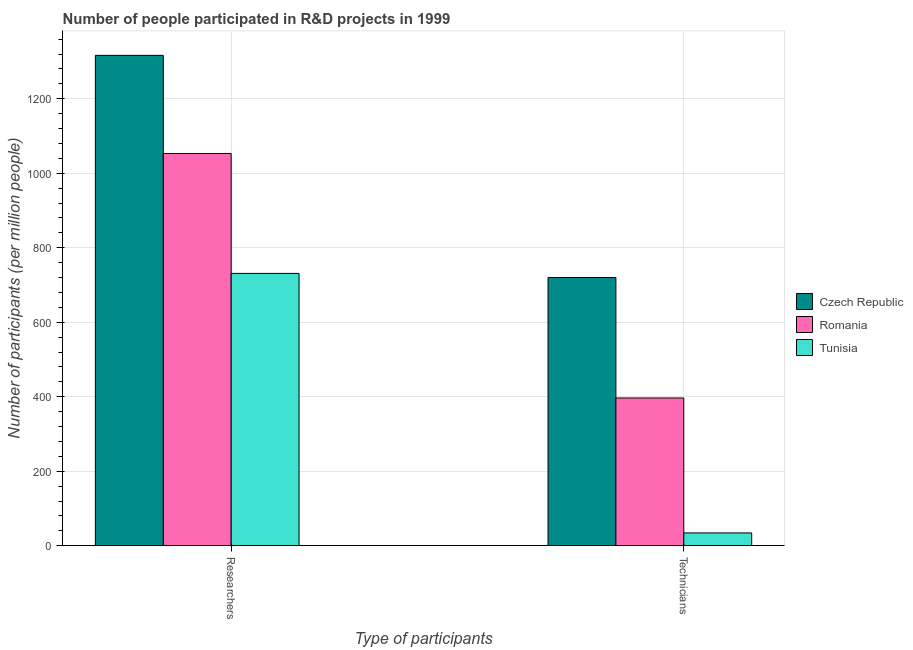How many different coloured bars are there?
Your response must be concise. 3. How many groups of bars are there?
Provide a short and direct response. 2. Are the number of bars per tick equal to the number of legend labels?
Your answer should be compact. Yes. Are the number of bars on each tick of the X-axis equal?
Your response must be concise. Yes. How many bars are there on the 1st tick from the left?
Provide a short and direct response. 3. What is the label of the 1st group of bars from the left?
Offer a very short reply. Researchers. What is the number of researchers in Czech Republic?
Ensure brevity in your answer.  1316.57. Across all countries, what is the maximum number of technicians?
Give a very brief answer. 720.1. Across all countries, what is the minimum number of researchers?
Offer a terse response. 731.21. In which country was the number of researchers maximum?
Provide a short and direct response. Czech Republic. In which country was the number of technicians minimum?
Your response must be concise. Tunisia. What is the total number of researchers in the graph?
Your answer should be compact. 3100.92. What is the difference between the number of researchers in Tunisia and that in Romania?
Provide a succinct answer. -321.93. What is the difference between the number of technicians in Czech Republic and the number of researchers in Romania?
Offer a very short reply. -333.04. What is the average number of researchers per country?
Ensure brevity in your answer.  1033.64. What is the difference between the number of researchers and number of technicians in Czech Republic?
Your answer should be compact. 596.47. In how many countries, is the number of technicians greater than 760 ?
Offer a terse response. 0. What is the ratio of the number of technicians in Romania to that in Czech Republic?
Offer a very short reply. 0.55. What does the 3rd bar from the left in Technicians represents?
Your answer should be compact. Tunisia. What does the 3rd bar from the right in Technicians represents?
Give a very brief answer. Czech Republic. How many bars are there?
Your answer should be compact. 6. Does the graph contain any zero values?
Make the answer very short. No. Does the graph contain grids?
Provide a succinct answer. Yes. How many legend labels are there?
Keep it short and to the point. 3. What is the title of the graph?
Give a very brief answer. Number of people participated in R&D projects in 1999. Does "Guam" appear as one of the legend labels in the graph?
Your answer should be compact. No. What is the label or title of the X-axis?
Your answer should be compact. Type of participants. What is the label or title of the Y-axis?
Make the answer very short. Number of participants (per million people). What is the Number of participants (per million people) of Czech Republic in Researchers?
Your answer should be very brief. 1316.57. What is the Number of participants (per million people) in Romania in Researchers?
Your response must be concise. 1053.14. What is the Number of participants (per million people) of Tunisia in Researchers?
Offer a terse response. 731.21. What is the Number of participants (per million people) of Czech Republic in Technicians?
Ensure brevity in your answer.  720.1. What is the Number of participants (per million people) in Romania in Technicians?
Provide a succinct answer. 396.75. What is the Number of participants (per million people) of Tunisia in Technicians?
Make the answer very short. 34.49. Across all Type of participants, what is the maximum Number of participants (per million people) in Czech Republic?
Provide a succinct answer. 1316.57. Across all Type of participants, what is the maximum Number of participants (per million people) in Romania?
Make the answer very short. 1053.14. Across all Type of participants, what is the maximum Number of participants (per million people) in Tunisia?
Your answer should be very brief. 731.21. Across all Type of participants, what is the minimum Number of participants (per million people) of Czech Republic?
Make the answer very short. 720.1. Across all Type of participants, what is the minimum Number of participants (per million people) of Romania?
Provide a short and direct response. 396.75. Across all Type of participants, what is the minimum Number of participants (per million people) in Tunisia?
Ensure brevity in your answer.  34.49. What is the total Number of participants (per million people) in Czech Republic in the graph?
Your response must be concise. 2036.67. What is the total Number of participants (per million people) of Romania in the graph?
Offer a very short reply. 1449.89. What is the total Number of participants (per million people) in Tunisia in the graph?
Provide a short and direct response. 765.7. What is the difference between the Number of participants (per million people) of Czech Republic in Researchers and that in Technicians?
Make the answer very short. 596.47. What is the difference between the Number of participants (per million people) of Romania in Researchers and that in Technicians?
Your answer should be very brief. 656.39. What is the difference between the Number of participants (per million people) in Tunisia in Researchers and that in Technicians?
Provide a short and direct response. 696.72. What is the difference between the Number of participants (per million people) of Czech Republic in Researchers and the Number of participants (per million people) of Romania in Technicians?
Give a very brief answer. 919.82. What is the difference between the Number of participants (per million people) in Czech Republic in Researchers and the Number of participants (per million people) in Tunisia in Technicians?
Keep it short and to the point. 1282.08. What is the difference between the Number of participants (per million people) in Romania in Researchers and the Number of participants (per million people) in Tunisia in Technicians?
Provide a short and direct response. 1018.65. What is the average Number of participants (per million people) in Czech Republic per Type of participants?
Offer a very short reply. 1018.33. What is the average Number of participants (per million people) in Romania per Type of participants?
Provide a short and direct response. 724.95. What is the average Number of participants (per million people) of Tunisia per Type of participants?
Offer a very short reply. 382.85. What is the difference between the Number of participants (per million people) of Czech Republic and Number of participants (per million people) of Romania in Researchers?
Offer a terse response. 263.43. What is the difference between the Number of participants (per million people) in Czech Republic and Number of participants (per million people) in Tunisia in Researchers?
Make the answer very short. 585.36. What is the difference between the Number of participants (per million people) of Romania and Number of participants (per million people) of Tunisia in Researchers?
Make the answer very short. 321.93. What is the difference between the Number of participants (per million people) of Czech Republic and Number of participants (per million people) of Romania in Technicians?
Provide a succinct answer. 323.35. What is the difference between the Number of participants (per million people) in Czech Republic and Number of participants (per million people) in Tunisia in Technicians?
Your response must be concise. 685.61. What is the difference between the Number of participants (per million people) of Romania and Number of participants (per million people) of Tunisia in Technicians?
Give a very brief answer. 362.26. What is the ratio of the Number of participants (per million people) in Czech Republic in Researchers to that in Technicians?
Offer a very short reply. 1.83. What is the ratio of the Number of participants (per million people) in Romania in Researchers to that in Technicians?
Provide a succinct answer. 2.65. What is the ratio of the Number of participants (per million people) in Tunisia in Researchers to that in Technicians?
Make the answer very short. 21.2. What is the difference between the highest and the second highest Number of participants (per million people) in Czech Republic?
Offer a terse response. 596.47. What is the difference between the highest and the second highest Number of participants (per million people) in Romania?
Ensure brevity in your answer.  656.39. What is the difference between the highest and the second highest Number of participants (per million people) in Tunisia?
Offer a terse response. 696.72. What is the difference between the highest and the lowest Number of participants (per million people) in Czech Republic?
Make the answer very short. 596.47. What is the difference between the highest and the lowest Number of participants (per million people) of Romania?
Provide a short and direct response. 656.39. What is the difference between the highest and the lowest Number of participants (per million people) in Tunisia?
Provide a short and direct response. 696.72. 